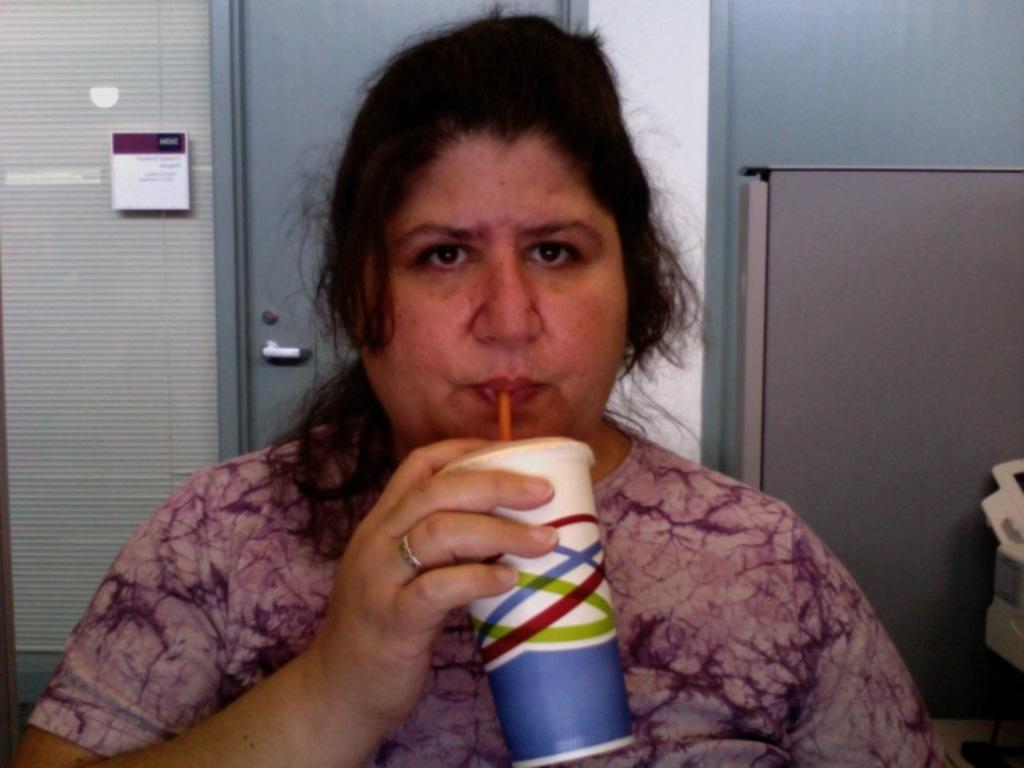Who is present in the image? There is a woman in the image. What is the woman doing in the image? The woman is drinking some liquid. What can be seen in the background of the image? There is a door visible in the background of the image. How many people are in the crowd in the image? There is no crowd present in the image; it features a woman drinking some liquid. What type of comfort can be seen in the image? There is no specific comfort item visible in the image, as it primarily focuses on the woman drinking liquid. 